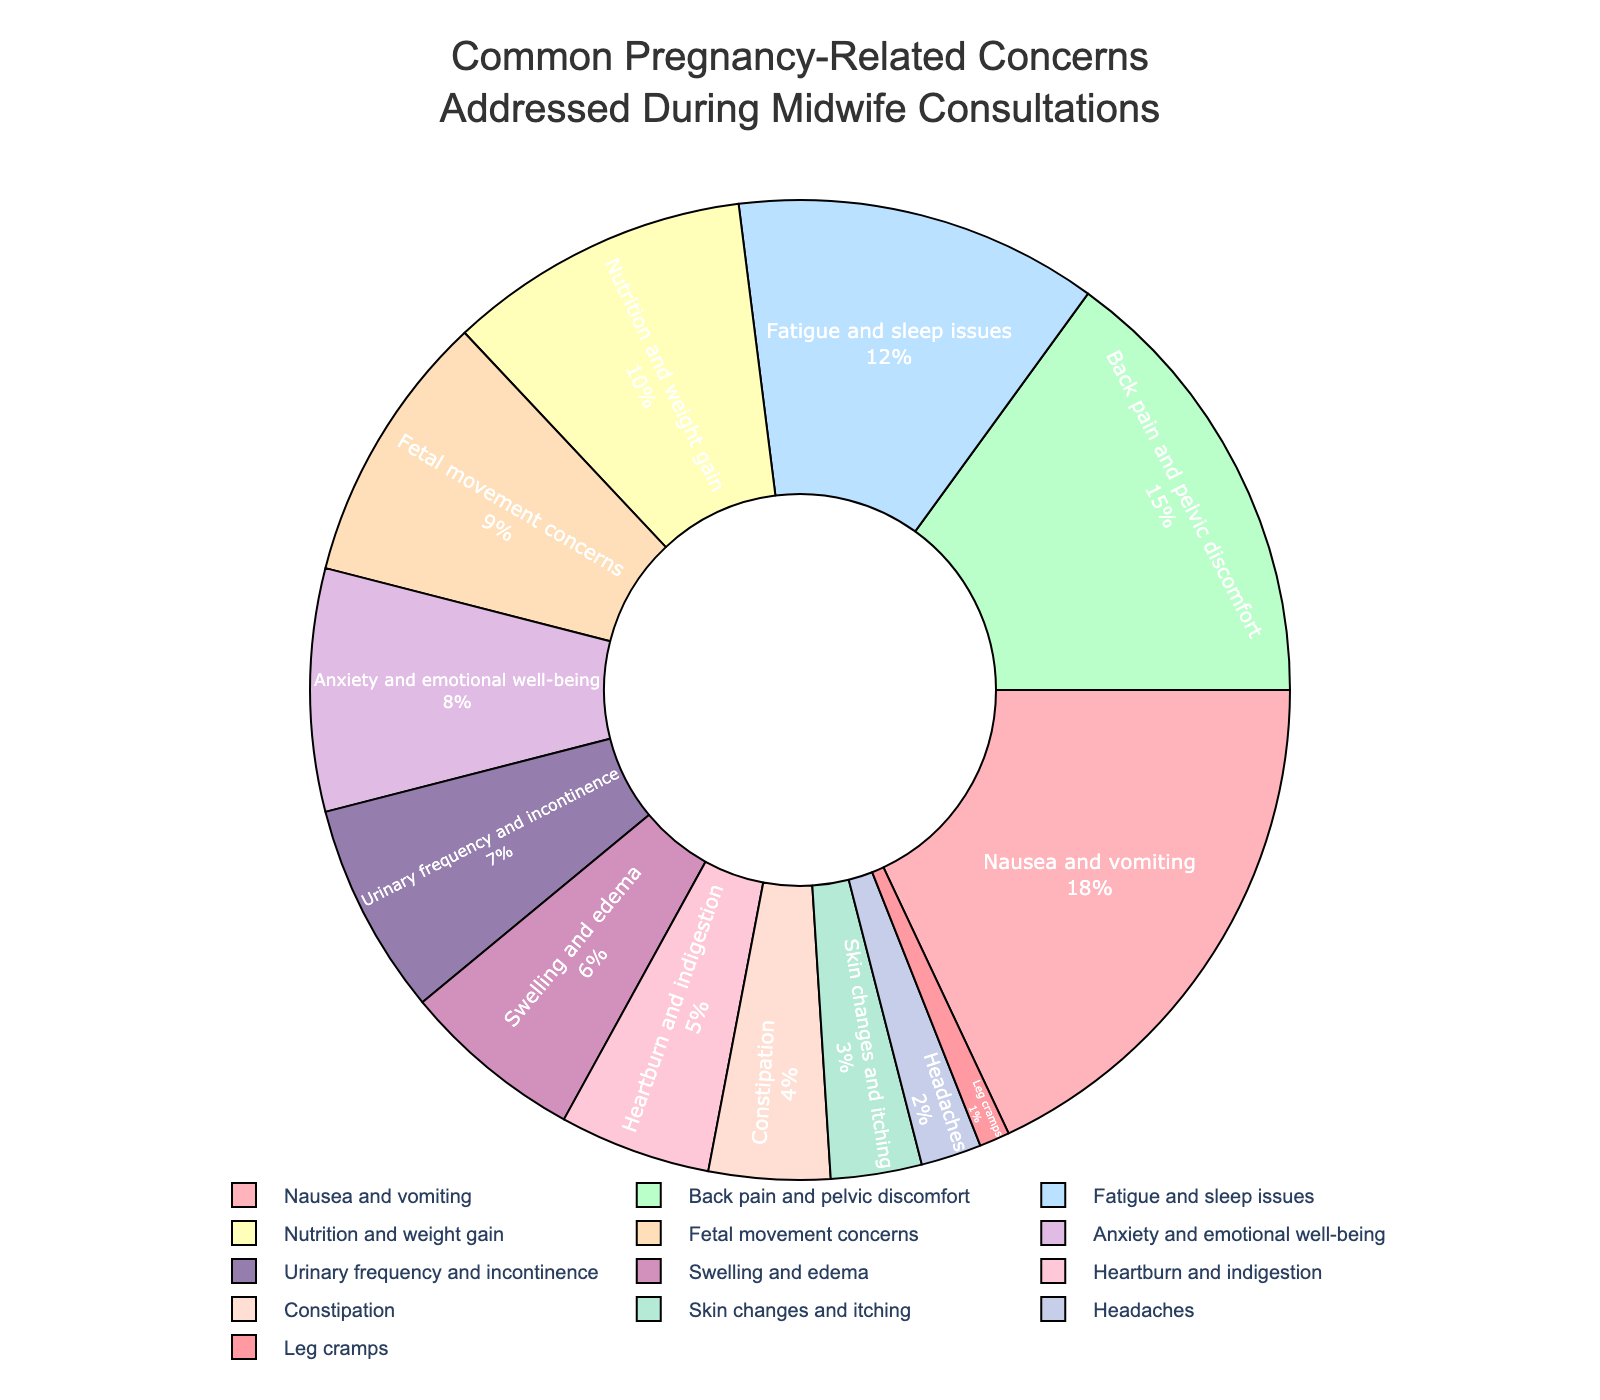Which category has the highest percentage of concerns addressed during midwife consultations? Look at the pie chart's segment labeled with the highest percentage.
Answer: Nausea and vomiting What is the total percentage for back pain and pelvic discomfort and fatigue and sleep issues combined? Sum the percentages for "Back pain and pelvic discomfort" (15%) and "Fatigue and sleep issues" (12%).
Answer: 27% Which category has a higher percentage: nutrition and weight gain or fetal movement concerns? Compare the percentages of "Nutrition and weight gain" (10%) and "Fetal movement concerns" (9%).
Answer: Nutrition and weight gain How many categories have a percentage of 5% or lower? Count the segments with percentages of 5% or less: Heartburn and indigestion (5%), Constipation (4%), Skin changes and itching (3%), Headaches (2%), Leg cramps (1%).
Answer: 5 What is the difference in percentage between anxiety and emotional well-being and urinary frequency and incontinence? Subtract the percentage for "Urinary frequency and incontinence" (7%) from the percentage for "Anxiety and emotional well-being" (8%).
Answer: 1% What percentage is represented by concerns about skin changes and itching? Find the segment labeled "Skin changes and itching" and note its percentage.
Answer: 3% Which categories combined equal less than or equal to 10%? Add the percentages of smaller categories until the total is ≤ 10%: Constipation (4%) + Skin changes and itching (3%) + Headaches (2%) + Leg cramps (1%).
Answer: Constipation, Skin changes and itching, Headaches, and Leg cramps Is the percentage for swelling and edema greater than that for heartburn and indigestion? Compare the percentages of "Swelling and edema" (6%) and "Heartburn and indigestion" (5%).
Answer: Yes What is the average percentage for urinary frequency and incontinence, swelling and edema, and heartburn and indigestion? Sum the percentages (7% + 6% + 5%) and divide by 3.
Answer: 6% From the visual representation, which color represents the category with the least concerns? Identify the segment with the smallest percentage (Leg cramps, 1%), and note its color.
Answer: Light blue 